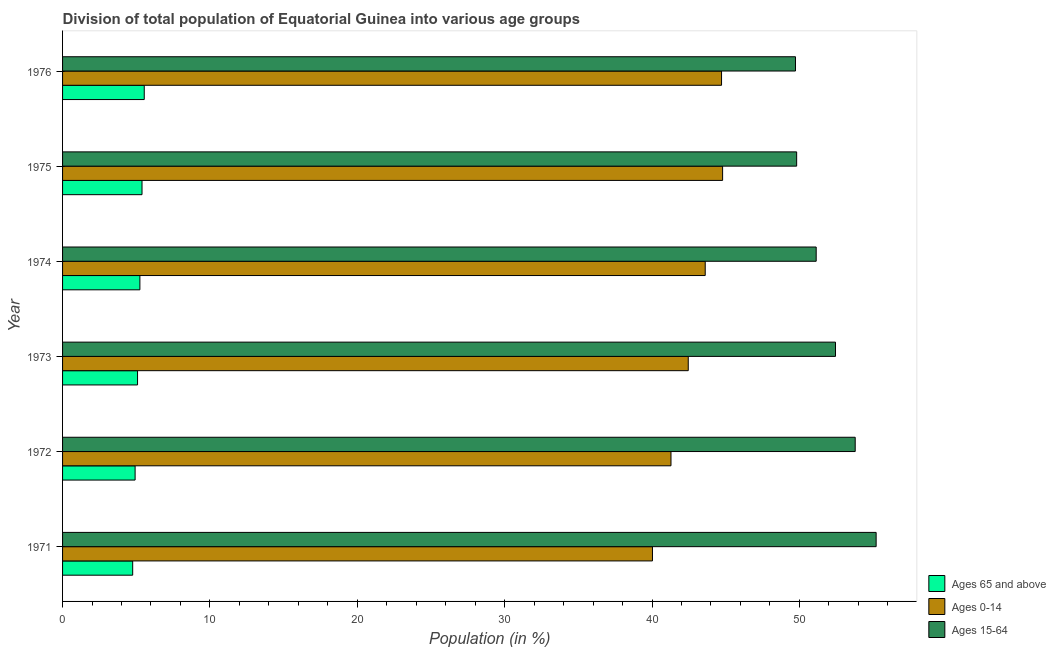How many different coloured bars are there?
Provide a succinct answer. 3. How many groups of bars are there?
Your response must be concise. 6. In how many cases, is the number of bars for a given year not equal to the number of legend labels?
Provide a succinct answer. 0. What is the percentage of population within the age-group of 65 and above in 1971?
Provide a short and direct response. 4.76. Across all years, what is the maximum percentage of population within the age-group 15-64?
Provide a succinct answer. 55.21. Across all years, what is the minimum percentage of population within the age-group 0-14?
Provide a short and direct response. 40.03. In which year was the percentage of population within the age-group of 65 and above maximum?
Ensure brevity in your answer.  1976. In which year was the percentage of population within the age-group 0-14 minimum?
Your answer should be compact. 1971. What is the total percentage of population within the age-group of 65 and above in the graph?
Ensure brevity in your answer.  30.95. What is the difference between the percentage of population within the age-group of 65 and above in 1972 and that in 1974?
Your response must be concise. -0.33. What is the difference between the percentage of population within the age-group 0-14 in 1976 and the percentage of population within the age-group 15-64 in 1975?
Offer a terse response. -5.1. What is the average percentage of population within the age-group of 65 and above per year?
Your response must be concise. 5.16. In the year 1972, what is the difference between the percentage of population within the age-group of 65 and above and percentage of population within the age-group 0-14?
Keep it short and to the point. -36.37. What is the ratio of the percentage of population within the age-group 0-14 in 1971 to that in 1976?
Your answer should be compact. 0.9. What is the difference between the highest and the second highest percentage of population within the age-group 15-64?
Provide a succinct answer. 1.42. What is the difference between the highest and the lowest percentage of population within the age-group of 65 and above?
Ensure brevity in your answer.  0.78. In how many years, is the percentage of population within the age-group 0-14 greater than the average percentage of population within the age-group 0-14 taken over all years?
Offer a very short reply. 3. What does the 2nd bar from the top in 1974 represents?
Your response must be concise. Ages 0-14. What does the 1st bar from the bottom in 1971 represents?
Keep it short and to the point. Ages 65 and above. Is it the case that in every year, the sum of the percentage of population within the age-group of 65 and above and percentage of population within the age-group 0-14 is greater than the percentage of population within the age-group 15-64?
Provide a succinct answer. No. Are all the bars in the graph horizontal?
Your answer should be very brief. Yes. What is the difference between two consecutive major ticks on the X-axis?
Provide a short and direct response. 10. Are the values on the major ticks of X-axis written in scientific E-notation?
Your answer should be very brief. No. What is the title of the graph?
Make the answer very short. Division of total population of Equatorial Guinea into various age groups
. What is the Population (in %) of Ages 65 and above in 1971?
Provide a short and direct response. 4.76. What is the Population (in %) of Ages 0-14 in 1971?
Provide a succinct answer. 40.03. What is the Population (in %) of Ages 15-64 in 1971?
Ensure brevity in your answer.  55.21. What is the Population (in %) in Ages 65 and above in 1972?
Provide a succinct answer. 4.92. What is the Population (in %) of Ages 0-14 in 1972?
Keep it short and to the point. 41.29. What is the Population (in %) of Ages 15-64 in 1972?
Offer a very short reply. 53.79. What is the Population (in %) of Ages 65 and above in 1973?
Provide a short and direct response. 5.09. What is the Population (in %) of Ages 0-14 in 1973?
Your answer should be compact. 42.46. What is the Population (in %) in Ages 15-64 in 1973?
Keep it short and to the point. 52.45. What is the Population (in %) of Ages 65 and above in 1974?
Offer a very short reply. 5.25. What is the Population (in %) of Ages 0-14 in 1974?
Give a very brief answer. 43.61. What is the Population (in %) in Ages 15-64 in 1974?
Make the answer very short. 51.14. What is the Population (in %) in Ages 65 and above in 1975?
Offer a terse response. 5.39. What is the Population (in %) of Ages 0-14 in 1975?
Your response must be concise. 44.79. What is the Population (in %) of Ages 15-64 in 1975?
Your answer should be compact. 49.82. What is the Population (in %) of Ages 65 and above in 1976?
Offer a very short reply. 5.54. What is the Population (in %) of Ages 0-14 in 1976?
Give a very brief answer. 44.72. What is the Population (in %) in Ages 15-64 in 1976?
Ensure brevity in your answer.  49.74. Across all years, what is the maximum Population (in %) of Ages 65 and above?
Provide a succinct answer. 5.54. Across all years, what is the maximum Population (in %) of Ages 0-14?
Provide a succinct answer. 44.79. Across all years, what is the maximum Population (in %) in Ages 15-64?
Your answer should be compact. 55.21. Across all years, what is the minimum Population (in %) of Ages 65 and above?
Offer a terse response. 4.76. Across all years, what is the minimum Population (in %) of Ages 0-14?
Offer a terse response. 40.03. Across all years, what is the minimum Population (in %) of Ages 15-64?
Provide a succinct answer. 49.74. What is the total Population (in %) of Ages 65 and above in the graph?
Provide a short and direct response. 30.95. What is the total Population (in %) in Ages 0-14 in the graph?
Make the answer very short. 256.9. What is the total Population (in %) in Ages 15-64 in the graph?
Offer a very short reply. 312.15. What is the difference between the Population (in %) of Ages 65 and above in 1971 and that in 1972?
Your answer should be very brief. -0.16. What is the difference between the Population (in %) of Ages 0-14 in 1971 and that in 1972?
Give a very brief answer. -1.26. What is the difference between the Population (in %) of Ages 15-64 in 1971 and that in 1972?
Provide a short and direct response. 1.42. What is the difference between the Population (in %) in Ages 65 and above in 1971 and that in 1973?
Offer a very short reply. -0.33. What is the difference between the Population (in %) in Ages 0-14 in 1971 and that in 1973?
Provide a short and direct response. -2.43. What is the difference between the Population (in %) of Ages 15-64 in 1971 and that in 1973?
Offer a very short reply. 2.76. What is the difference between the Population (in %) of Ages 65 and above in 1971 and that in 1974?
Keep it short and to the point. -0.49. What is the difference between the Population (in %) of Ages 0-14 in 1971 and that in 1974?
Give a very brief answer. -3.58. What is the difference between the Population (in %) of Ages 15-64 in 1971 and that in 1974?
Keep it short and to the point. 4.07. What is the difference between the Population (in %) of Ages 65 and above in 1971 and that in 1975?
Your answer should be very brief. -0.63. What is the difference between the Population (in %) in Ages 0-14 in 1971 and that in 1975?
Keep it short and to the point. -4.76. What is the difference between the Population (in %) of Ages 15-64 in 1971 and that in 1975?
Make the answer very short. 5.39. What is the difference between the Population (in %) in Ages 65 and above in 1971 and that in 1976?
Your answer should be compact. -0.78. What is the difference between the Population (in %) of Ages 0-14 in 1971 and that in 1976?
Make the answer very short. -4.69. What is the difference between the Population (in %) of Ages 15-64 in 1971 and that in 1976?
Make the answer very short. 5.47. What is the difference between the Population (in %) of Ages 65 and above in 1972 and that in 1973?
Give a very brief answer. -0.17. What is the difference between the Population (in %) in Ages 0-14 in 1972 and that in 1973?
Keep it short and to the point. -1.17. What is the difference between the Population (in %) in Ages 15-64 in 1972 and that in 1973?
Ensure brevity in your answer.  1.34. What is the difference between the Population (in %) in Ages 65 and above in 1972 and that in 1974?
Your answer should be compact. -0.33. What is the difference between the Population (in %) in Ages 0-14 in 1972 and that in 1974?
Make the answer very short. -2.32. What is the difference between the Population (in %) of Ages 15-64 in 1972 and that in 1974?
Keep it short and to the point. 2.65. What is the difference between the Population (in %) in Ages 65 and above in 1972 and that in 1975?
Provide a short and direct response. -0.47. What is the difference between the Population (in %) of Ages 0-14 in 1972 and that in 1975?
Make the answer very short. -3.5. What is the difference between the Population (in %) in Ages 15-64 in 1972 and that in 1975?
Keep it short and to the point. 3.97. What is the difference between the Population (in %) in Ages 65 and above in 1972 and that in 1976?
Your answer should be very brief. -0.62. What is the difference between the Population (in %) in Ages 0-14 in 1972 and that in 1976?
Provide a short and direct response. -3.43. What is the difference between the Population (in %) of Ages 15-64 in 1972 and that in 1976?
Provide a succinct answer. 4.05. What is the difference between the Population (in %) in Ages 65 and above in 1973 and that in 1974?
Offer a very short reply. -0.16. What is the difference between the Population (in %) of Ages 0-14 in 1973 and that in 1974?
Provide a succinct answer. -1.15. What is the difference between the Population (in %) of Ages 15-64 in 1973 and that in 1974?
Give a very brief answer. 1.31. What is the difference between the Population (in %) of Ages 65 and above in 1973 and that in 1975?
Your answer should be compact. -0.3. What is the difference between the Population (in %) in Ages 0-14 in 1973 and that in 1975?
Your answer should be very brief. -2.33. What is the difference between the Population (in %) in Ages 15-64 in 1973 and that in 1975?
Keep it short and to the point. 2.64. What is the difference between the Population (in %) of Ages 65 and above in 1973 and that in 1976?
Ensure brevity in your answer.  -0.46. What is the difference between the Population (in %) of Ages 0-14 in 1973 and that in 1976?
Offer a very short reply. -2.26. What is the difference between the Population (in %) in Ages 15-64 in 1973 and that in 1976?
Keep it short and to the point. 2.71. What is the difference between the Population (in %) of Ages 65 and above in 1974 and that in 1975?
Your response must be concise. -0.14. What is the difference between the Population (in %) in Ages 0-14 in 1974 and that in 1975?
Provide a succinct answer. -1.18. What is the difference between the Population (in %) in Ages 15-64 in 1974 and that in 1975?
Keep it short and to the point. 1.33. What is the difference between the Population (in %) in Ages 65 and above in 1974 and that in 1976?
Your answer should be compact. -0.3. What is the difference between the Population (in %) of Ages 0-14 in 1974 and that in 1976?
Provide a short and direct response. -1.11. What is the difference between the Population (in %) in Ages 15-64 in 1974 and that in 1976?
Your response must be concise. 1.4. What is the difference between the Population (in %) in Ages 65 and above in 1975 and that in 1976?
Keep it short and to the point. -0.15. What is the difference between the Population (in %) in Ages 0-14 in 1975 and that in 1976?
Your answer should be compact. 0.07. What is the difference between the Population (in %) in Ages 15-64 in 1975 and that in 1976?
Provide a succinct answer. 0.08. What is the difference between the Population (in %) of Ages 65 and above in 1971 and the Population (in %) of Ages 0-14 in 1972?
Your response must be concise. -36.53. What is the difference between the Population (in %) of Ages 65 and above in 1971 and the Population (in %) of Ages 15-64 in 1972?
Provide a short and direct response. -49.03. What is the difference between the Population (in %) of Ages 0-14 in 1971 and the Population (in %) of Ages 15-64 in 1972?
Give a very brief answer. -13.76. What is the difference between the Population (in %) in Ages 65 and above in 1971 and the Population (in %) in Ages 0-14 in 1973?
Ensure brevity in your answer.  -37.7. What is the difference between the Population (in %) of Ages 65 and above in 1971 and the Population (in %) of Ages 15-64 in 1973?
Keep it short and to the point. -47.69. What is the difference between the Population (in %) of Ages 0-14 in 1971 and the Population (in %) of Ages 15-64 in 1973?
Your answer should be very brief. -12.42. What is the difference between the Population (in %) of Ages 65 and above in 1971 and the Population (in %) of Ages 0-14 in 1974?
Provide a succinct answer. -38.85. What is the difference between the Population (in %) of Ages 65 and above in 1971 and the Population (in %) of Ages 15-64 in 1974?
Offer a terse response. -46.38. What is the difference between the Population (in %) of Ages 0-14 in 1971 and the Population (in %) of Ages 15-64 in 1974?
Provide a succinct answer. -11.11. What is the difference between the Population (in %) of Ages 65 and above in 1971 and the Population (in %) of Ages 0-14 in 1975?
Make the answer very short. -40.03. What is the difference between the Population (in %) of Ages 65 and above in 1971 and the Population (in %) of Ages 15-64 in 1975?
Keep it short and to the point. -45.06. What is the difference between the Population (in %) in Ages 0-14 in 1971 and the Population (in %) in Ages 15-64 in 1975?
Provide a succinct answer. -9.78. What is the difference between the Population (in %) of Ages 65 and above in 1971 and the Population (in %) of Ages 0-14 in 1976?
Your answer should be very brief. -39.96. What is the difference between the Population (in %) in Ages 65 and above in 1971 and the Population (in %) in Ages 15-64 in 1976?
Provide a succinct answer. -44.98. What is the difference between the Population (in %) in Ages 0-14 in 1971 and the Population (in %) in Ages 15-64 in 1976?
Make the answer very short. -9.71. What is the difference between the Population (in %) of Ages 65 and above in 1972 and the Population (in %) of Ages 0-14 in 1973?
Your answer should be very brief. -37.54. What is the difference between the Population (in %) of Ages 65 and above in 1972 and the Population (in %) of Ages 15-64 in 1973?
Keep it short and to the point. -47.53. What is the difference between the Population (in %) of Ages 0-14 in 1972 and the Population (in %) of Ages 15-64 in 1973?
Ensure brevity in your answer.  -11.16. What is the difference between the Population (in %) of Ages 65 and above in 1972 and the Population (in %) of Ages 0-14 in 1974?
Provide a short and direct response. -38.69. What is the difference between the Population (in %) of Ages 65 and above in 1972 and the Population (in %) of Ages 15-64 in 1974?
Offer a very short reply. -46.22. What is the difference between the Population (in %) of Ages 0-14 in 1972 and the Population (in %) of Ages 15-64 in 1974?
Offer a terse response. -9.85. What is the difference between the Population (in %) of Ages 65 and above in 1972 and the Population (in %) of Ages 0-14 in 1975?
Ensure brevity in your answer.  -39.87. What is the difference between the Population (in %) of Ages 65 and above in 1972 and the Population (in %) of Ages 15-64 in 1975?
Offer a terse response. -44.89. What is the difference between the Population (in %) of Ages 0-14 in 1972 and the Population (in %) of Ages 15-64 in 1975?
Your answer should be very brief. -8.53. What is the difference between the Population (in %) of Ages 65 and above in 1972 and the Population (in %) of Ages 0-14 in 1976?
Ensure brevity in your answer.  -39.8. What is the difference between the Population (in %) of Ages 65 and above in 1972 and the Population (in %) of Ages 15-64 in 1976?
Provide a succinct answer. -44.81. What is the difference between the Population (in %) in Ages 0-14 in 1972 and the Population (in %) in Ages 15-64 in 1976?
Offer a terse response. -8.45. What is the difference between the Population (in %) in Ages 65 and above in 1973 and the Population (in %) in Ages 0-14 in 1974?
Provide a succinct answer. -38.52. What is the difference between the Population (in %) in Ages 65 and above in 1973 and the Population (in %) in Ages 15-64 in 1974?
Provide a succinct answer. -46.05. What is the difference between the Population (in %) in Ages 0-14 in 1973 and the Population (in %) in Ages 15-64 in 1974?
Give a very brief answer. -8.68. What is the difference between the Population (in %) in Ages 65 and above in 1973 and the Population (in %) in Ages 0-14 in 1975?
Your response must be concise. -39.7. What is the difference between the Population (in %) in Ages 65 and above in 1973 and the Population (in %) in Ages 15-64 in 1975?
Make the answer very short. -44.73. What is the difference between the Population (in %) of Ages 0-14 in 1973 and the Population (in %) of Ages 15-64 in 1975?
Your answer should be compact. -7.36. What is the difference between the Population (in %) of Ages 65 and above in 1973 and the Population (in %) of Ages 0-14 in 1976?
Your answer should be compact. -39.63. What is the difference between the Population (in %) of Ages 65 and above in 1973 and the Population (in %) of Ages 15-64 in 1976?
Keep it short and to the point. -44.65. What is the difference between the Population (in %) of Ages 0-14 in 1973 and the Population (in %) of Ages 15-64 in 1976?
Offer a terse response. -7.28. What is the difference between the Population (in %) of Ages 65 and above in 1974 and the Population (in %) of Ages 0-14 in 1975?
Ensure brevity in your answer.  -39.54. What is the difference between the Population (in %) in Ages 65 and above in 1974 and the Population (in %) in Ages 15-64 in 1975?
Your answer should be very brief. -44.57. What is the difference between the Population (in %) of Ages 0-14 in 1974 and the Population (in %) of Ages 15-64 in 1975?
Offer a terse response. -6.21. What is the difference between the Population (in %) of Ages 65 and above in 1974 and the Population (in %) of Ages 0-14 in 1976?
Provide a succinct answer. -39.47. What is the difference between the Population (in %) in Ages 65 and above in 1974 and the Population (in %) in Ages 15-64 in 1976?
Provide a short and direct response. -44.49. What is the difference between the Population (in %) of Ages 0-14 in 1974 and the Population (in %) of Ages 15-64 in 1976?
Provide a short and direct response. -6.13. What is the difference between the Population (in %) in Ages 65 and above in 1975 and the Population (in %) in Ages 0-14 in 1976?
Your response must be concise. -39.33. What is the difference between the Population (in %) in Ages 65 and above in 1975 and the Population (in %) in Ages 15-64 in 1976?
Your response must be concise. -44.35. What is the difference between the Population (in %) of Ages 0-14 in 1975 and the Population (in %) of Ages 15-64 in 1976?
Provide a succinct answer. -4.95. What is the average Population (in %) of Ages 65 and above per year?
Offer a very short reply. 5.16. What is the average Population (in %) of Ages 0-14 per year?
Offer a very short reply. 42.82. What is the average Population (in %) of Ages 15-64 per year?
Give a very brief answer. 52.02. In the year 1971, what is the difference between the Population (in %) of Ages 65 and above and Population (in %) of Ages 0-14?
Your answer should be very brief. -35.27. In the year 1971, what is the difference between the Population (in %) of Ages 65 and above and Population (in %) of Ages 15-64?
Offer a very short reply. -50.45. In the year 1971, what is the difference between the Population (in %) of Ages 0-14 and Population (in %) of Ages 15-64?
Your answer should be very brief. -15.18. In the year 1972, what is the difference between the Population (in %) of Ages 65 and above and Population (in %) of Ages 0-14?
Your response must be concise. -36.37. In the year 1972, what is the difference between the Population (in %) of Ages 65 and above and Population (in %) of Ages 15-64?
Your answer should be compact. -48.87. In the year 1972, what is the difference between the Population (in %) of Ages 0-14 and Population (in %) of Ages 15-64?
Offer a terse response. -12.5. In the year 1973, what is the difference between the Population (in %) of Ages 65 and above and Population (in %) of Ages 0-14?
Provide a short and direct response. -37.37. In the year 1973, what is the difference between the Population (in %) of Ages 65 and above and Population (in %) of Ages 15-64?
Offer a very short reply. -47.36. In the year 1973, what is the difference between the Population (in %) in Ages 0-14 and Population (in %) in Ages 15-64?
Provide a short and direct response. -9.99. In the year 1974, what is the difference between the Population (in %) of Ages 65 and above and Population (in %) of Ages 0-14?
Ensure brevity in your answer.  -38.36. In the year 1974, what is the difference between the Population (in %) in Ages 65 and above and Population (in %) in Ages 15-64?
Keep it short and to the point. -45.89. In the year 1974, what is the difference between the Population (in %) in Ages 0-14 and Population (in %) in Ages 15-64?
Give a very brief answer. -7.53. In the year 1975, what is the difference between the Population (in %) in Ages 65 and above and Population (in %) in Ages 0-14?
Make the answer very short. -39.4. In the year 1975, what is the difference between the Population (in %) in Ages 65 and above and Population (in %) in Ages 15-64?
Provide a succinct answer. -44.42. In the year 1975, what is the difference between the Population (in %) of Ages 0-14 and Population (in %) of Ages 15-64?
Your answer should be compact. -5.02. In the year 1976, what is the difference between the Population (in %) of Ages 65 and above and Population (in %) of Ages 0-14?
Provide a succinct answer. -39.18. In the year 1976, what is the difference between the Population (in %) in Ages 65 and above and Population (in %) in Ages 15-64?
Provide a succinct answer. -44.19. In the year 1976, what is the difference between the Population (in %) of Ages 0-14 and Population (in %) of Ages 15-64?
Make the answer very short. -5.02. What is the ratio of the Population (in %) in Ages 65 and above in 1971 to that in 1972?
Provide a short and direct response. 0.97. What is the ratio of the Population (in %) in Ages 0-14 in 1971 to that in 1972?
Your response must be concise. 0.97. What is the ratio of the Population (in %) in Ages 15-64 in 1971 to that in 1972?
Your answer should be very brief. 1.03. What is the ratio of the Population (in %) of Ages 65 and above in 1971 to that in 1973?
Offer a terse response. 0.94. What is the ratio of the Population (in %) of Ages 0-14 in 1971 to that in 1973?
Your answer should be very brief. 0.94. What is the ratio of the Population (in %) in Ages 15-64 in 1971 to that in 1973?
Your response must be concise. 1.05. What is the ratio of the Population (in %) in Ages 65 and above in 1971 to that in 1974?
Provide a short and direct response. 0.91. What is the ratio of the Population (in %) in Ages 0-14 in 1971 to that in 1974?
Your response must be concise. 0.92. What is the ratio of the Population (in %) of Ages 15-64 in 1971 to that in 1974?
Offer a terse response. 1.08. What is the ratio of the Population (in %) in Ages 65 and above in 1971 to that in 1975?
Keep it short and to the point. 0.88. What is the ratio of the Population (in %) in Ages 0-14 in 1971 to that in 1975?
Provide a short and direct response. 0.89. What is the ratio of the Population (in %) of Ages 15-64 in 1971 to that in 1975?
Your response must be concise. 1.11. What is the ratio of the Population (in %) of Ages 65 and above in 1971 to that in 1976?
Provide a short and direct response. 0.86. What is the ratio of the Population (in %) of Ages 0-14 in 1971 to that in 1976?
Offer a terse response. 0.9. What is the ratio of the Population (in %) in Ages 15-64 in 1971 to that in 1976?
Offer a terse response. 1.11. What is the ratio of the Population (in %) in Ages 65 and above in 1972 to that in 1973?
Give a very brief answer. 0.97. What is the ratio of the Population (in %) of Ages 0-14 in 1972 to that in 1973?
Give a very brief answer. 0.97. What is the ratio of the Population (in %) in Ages 15-64 in 1972 to that in 1973?
Ensure brevity in your answer.  1.03. What is the ratio of the Population (in %) in Ages 65 and above in 1972 to that in 1974?
Make the answer very short. 0.94. What is the ratio of the Population (in %) in Ages 0-14 in 1972 to that in 1974?
Offer a terse response. 0.95. What is the ratio of the Population (in %) of Ages 15-64 in 1972 to that in 1974?
Your response must be concise. 1.05. What is the ratio of the Population (in %) of Ages 65 and above in 1972 to that in 1975?
Keep it short and to the point. 0.91. What is the ratio of the Population (in %) in Ages 0-14 in 1972 to that in 1975?
Give a very brief answer. 0.92. What is the ratio of the Population (in %) in Ages 15-64 in 1972 to that in 1975?
Make the answer very short. 1.08. What is the ratio of the Population (in %) of Ages 65 and above in 1972 to that in 1976?
Your response must be concise. 0.89. What is the ratio of the Population (in %) in Ages 0-14 in 1972 to that in 1976?
Ensure brevity in your answer.  0.92. What is the ratio of the Population (in %) of Ages 15-64 in 1972 to that in 1976?
Keep it short and to the point. 1.08. What is the ratio of the Population (in %) of Ages 65 and above in 1973 to that in 1974?
Offer a very short reply. 0.97. What is the ratio of the Population (in %) of Ages 0-14 in 1973 to that in 1974?
Ensure brevity in your answer.  0.97. What is the ratio of the Population (in %) in Ages 15-64 in 1973 to that in 1974?
Provide a succinct answer. 1.03. What is the ratio of the Population (in %) in Ages 65 and above in 1973 to that in 1975?
Your response must be concise. 0.94. What is the ratio of the Population (in %) of Ages 0-14 in 1973 to that in 1975?
Make the answer very short. 0.95. What is the ratio of the Population (in %) of Ages 15-64 in 1973 to that in 1975?
Provide a succinct answer. 1.05. What is the ratio of the Population (in %) in Ages 65 and above in 1973 to that in 1976?
Provide a succinct answer. 0.92. What is the ratio of the Population (in %) in Ages 0-14 in 1973 to that in 1976?
Provide a succinct answer. 0.95. What is the ratio of the Population (in %) of Ages 15-64 in 1973 to that in 1976?
Your response must be concise. 1.05. What is the ratio of the Population (in %) of Ages 65 and above in 1974 to that in 1975?
Ensure brevity in your answer.  0.97. What is the ratio of the Population (in %) of Ages 0-14 in 1974 to that in 1975?
Make the answer very short. 0.97. What is the ratio of the Population (in %) in Ages 15-64 in 1974 to that in 1975?
Make the answer very short. 1.03. What is the ratio of the Population (in %) of Ages 65 and above in 1974 to that in 1976?
Give a very brief answer. 0.95. What is the ratio of the Population (in %) in Ages 0-14 in 1974 to that in 1976?
Give a very brief answer. 0.98. What is the ratio of the Population (in %) in Ages 15-64 in 1974 to that in 1976?
Give a very brief answer. 1.03. What is the ratio of the Population (in %) in Ages 65 and above in 1975 to that in 1976?
Your answer should be compact. 0.97. What is the ratio of the Population (in %) in Ages 15-64 in 1975 to that in 1976?
Provide a succinct answer. 1. What is the difference between the highest and the second highest Population (in %) of Ages 65 and above?
Offer a very short reply. 0.15. What is the difference between the highest and the second highest Population (in %) in Ages 0-14?
Ensure brevity in your answer.  0.07. What is the difference between the highest and the second highest Population (in %) of Ages 15-64?
Your answer should be very brief. 1.42. What is the difference between the highest and the lowest Population (in %) in Ages 65 and above?
Give a very brief answer. 0.78. What is the difference between the highest and the lowest Population (in %) in Ages 0-14?
Your answer should be compact. 4.76. What is the difference between the highest and the lowest Population (in %) of Ages 15-64?
Your response must be concise. 5.47. 